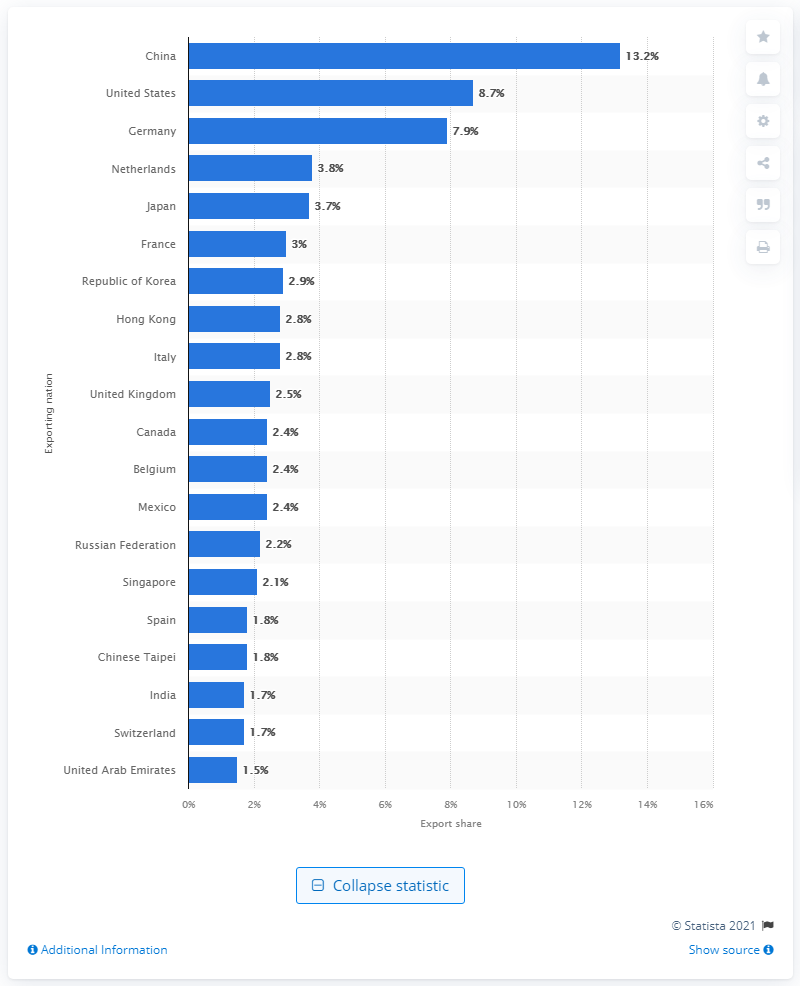Give some essential details in this illustration. The export share of the United States in 2019 was 8.7%. 